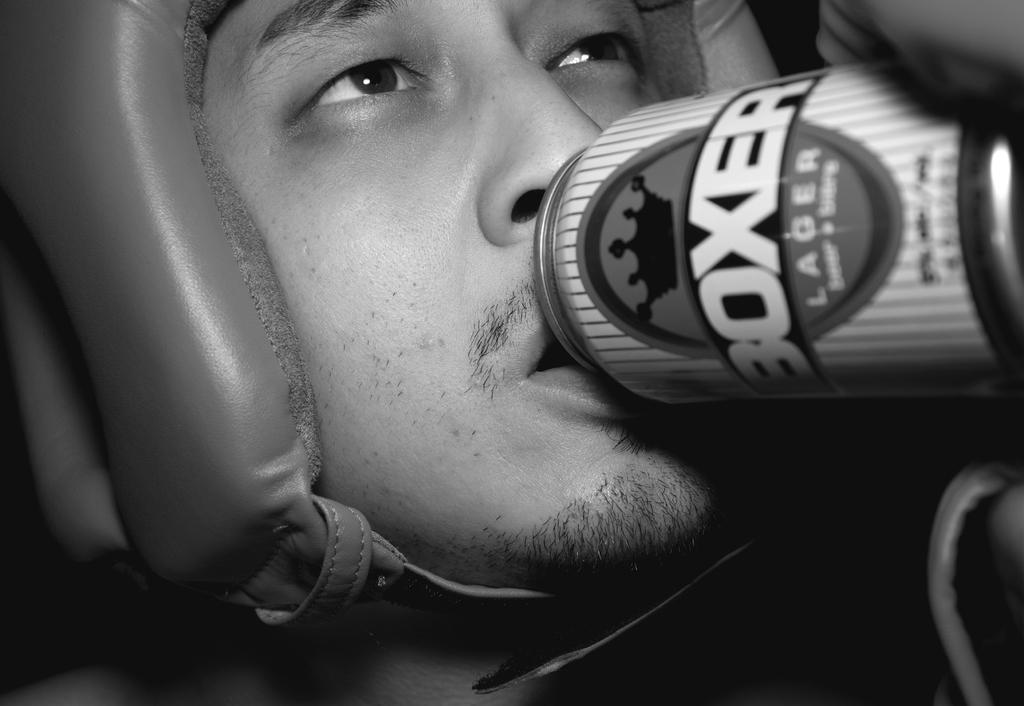What type of beverage is this?
Your answer should be compact. Lager. 